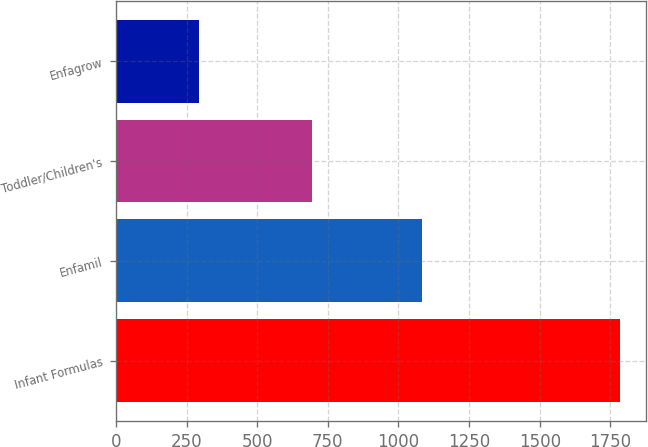Convert chart. <chart><loc_0><loc_0><loc_500><loc_500><bar_chart><fcel>Infant Formulas<fcel>Enfamil<fcel>Toddler/Children's<fcel>Enfagrow<nl><fcel>1786<fcel>1082<fcel>693<fcel>295<nl></chart> 